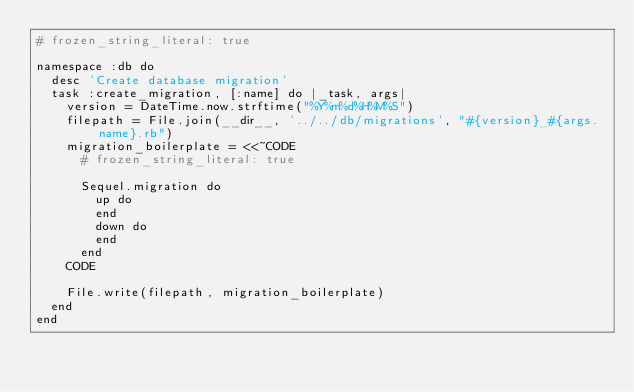Convert code to text. <code><loc_0><loc_0><loc_500><loc_500><_Ruby_># frozen_string_literal: true

namespace :db do
  desc 'Create database migration'
  task :create_migration, [:name] do |_task, args|
    version = DateTime.now.strftime("%Y%m%d%H%M%S")
    filepath = File.join(__dir__, '../../db/migrations', "#{version}_#{args.name}.rb")
    migration_boilerplate = <<~CODE
      # frozen_string_literal: true
      
      Sequel.migration do
        up do
        end
        down do
        end
      end
    CODE

    File.write(filepath, migration_boilerplate)
  end
end
</code> 